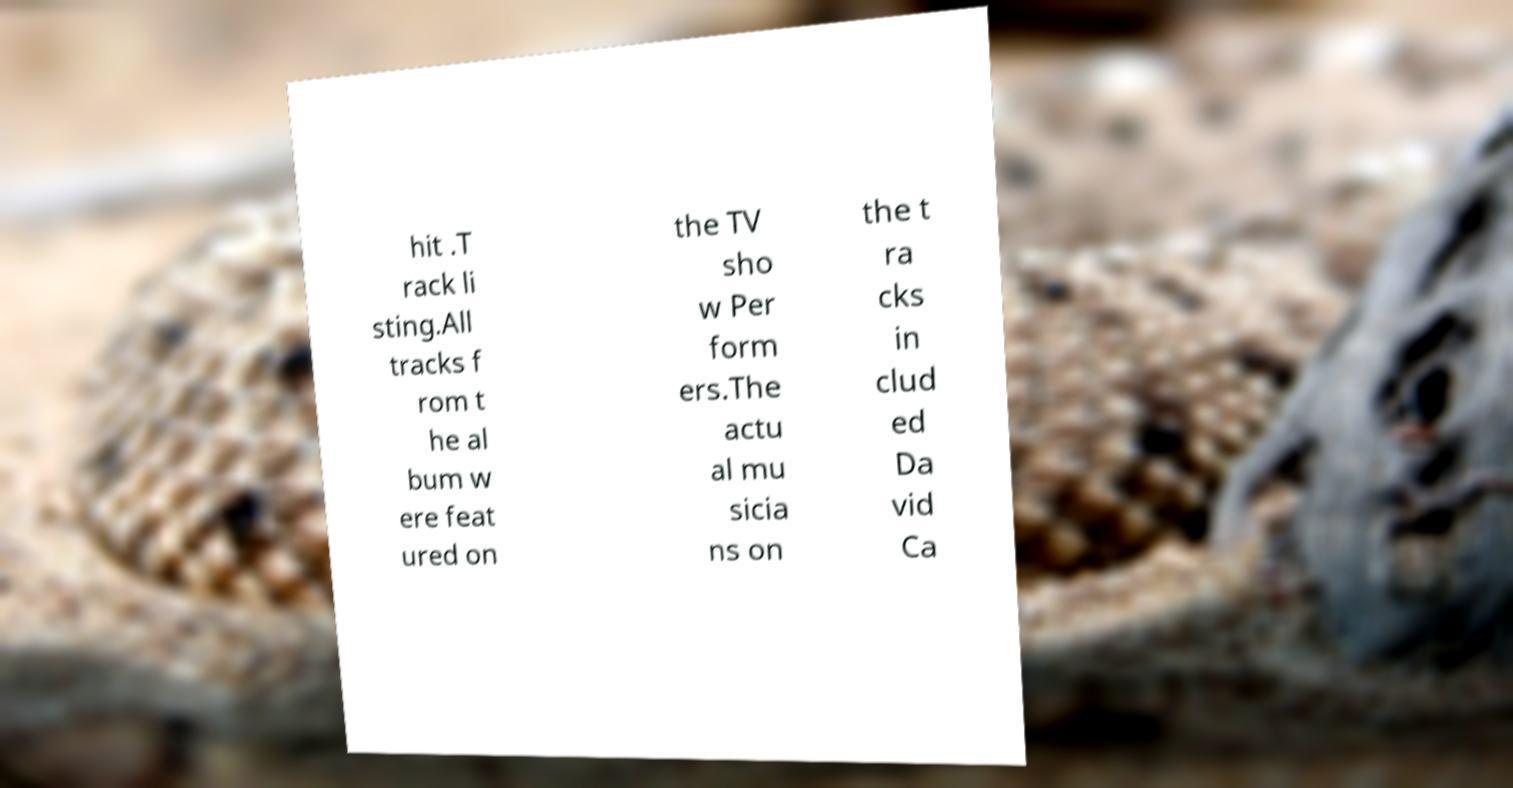For documentation purposes, I need the text within this image transcribed. Could you provide that? hit .T rack li sting.All tracks f rom t he al bum w ere feat ured on the TV sho w Per form ers.The actu al mu sicia ns on the t ra cks in clud ed Da vid Ca 